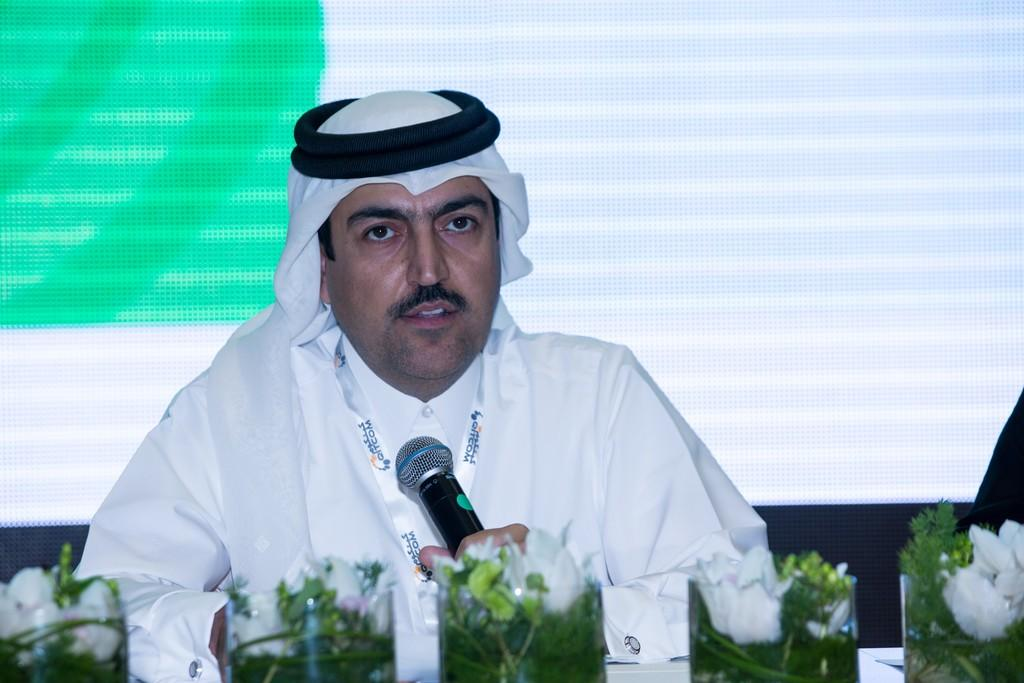What is the person in the image doing? The person is sitting in the image and holding a mic in his hands. What else can be seen in the image besides the person? There are flower bouquets in the image. What type of clouds can be seen in the image? There are no clouds present in the image; it only features a person sitting with a mic and flower bouquets. 